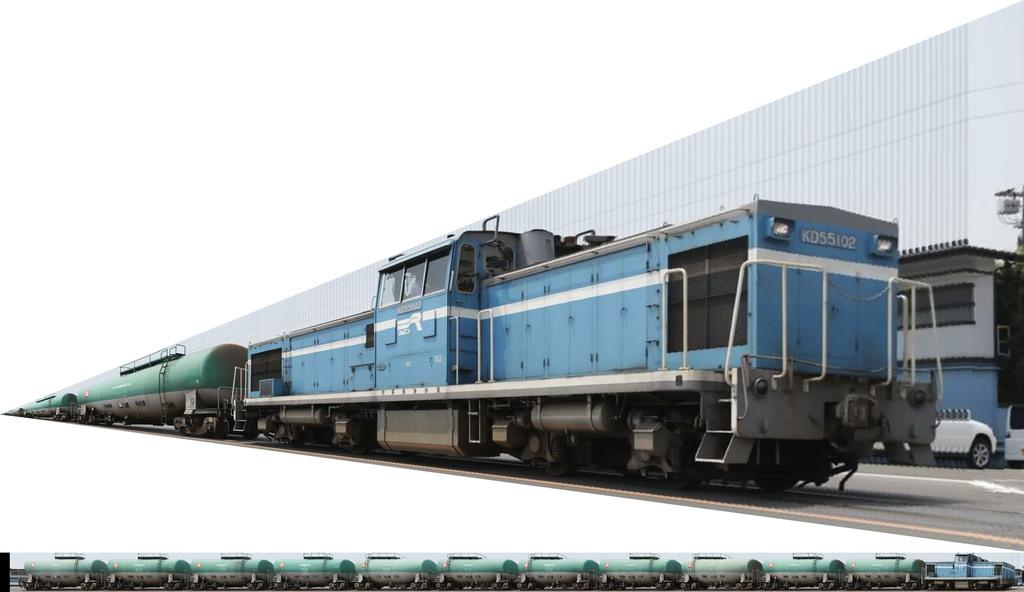What is the main subject in the center of the image? There is a train in the center of the image. What can be seen in the background of the image? There is a building and vehicles in the background of the image. Can you describe the position of the train in the image? There is a train at the bottom of the image. What type of chair is visible in the image? There is no chair present in the image. What is the reason for the train being in the image? The image does not provide any information about the reason for the train being there. 